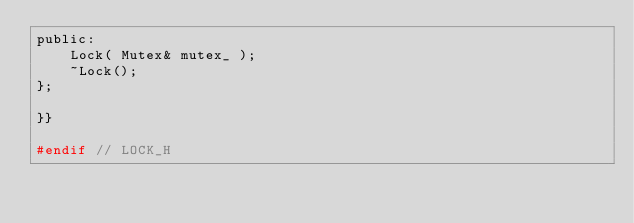Convert code to text. <code><loc_0><loc_0><loc_500><loc_500><_C_>public:
    Lock( Mutex& mutex_ );
    ~Lock();
};

}}

#endif // LOCK_H
</code> 